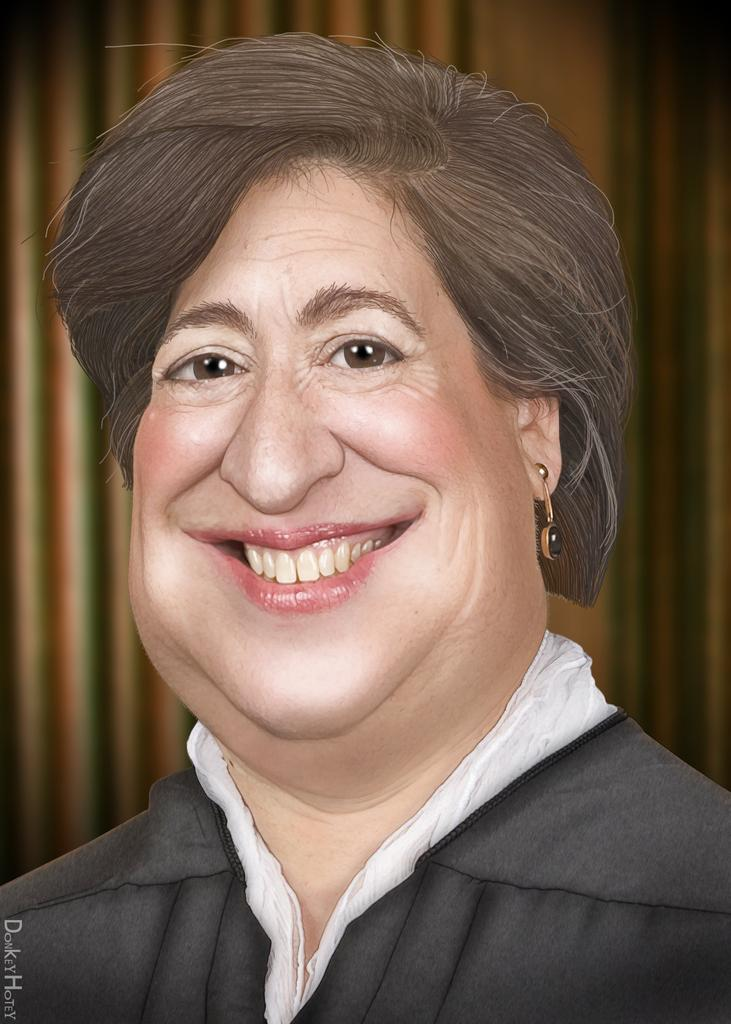What is the main subject of the picture? The main subject of the picture is an image of a woman. What is the woman's facial expression in the image? The woman is smiling in the image. Is there any text present in the image? Yes, there is text written in the left corner of the image. What type of fish can be seen swimming near the woman in the image? There is no fish present in the image; it features an image of a woman with text in the left corner. How many light bulbs are visible in the image? There are no light bulbs present in the image. 